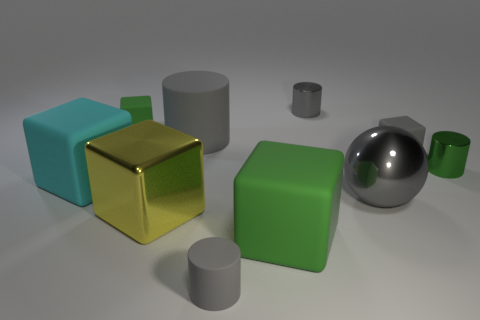What number of small matte objects have the same color as the large rubber cylinder?
Ensure brevity in your answer.  2. What number of objects are matte cubes that are in front of the big cyan matte object or objects in front of the large yellow thing?
Keep it short and to the point. 2. Are there more big matte objects than blocks?
Offer a very short reply. No. What color is the tiny matte object that is right of the big gray metal thing?
Make the answer very short. Gray. Is the shape of the large gray rubber thing the same as the big green rubber thing?
Your response must be concise. No. There is a small rubber object that is to the left of the gray matte block and behind the yellow metal thing; what is its color?
Ensure brevity in your answer.  Green. There is a green thing left of the large yellow metallic thing; is its size the same as the gray rubber cylinder that is behind the large yellow metal block?
Provide a succinct answer. No. How many objects are either tiny matte objects that are in front of the gray ball or matte cylinders?
Give a very brief answer. 2. What is the material of the small green block?
Ensure brevity in your answer.  Rubber. Does the gray metallic cylinder have the same size as the cyan matte block?
Your response must be concise. No. 